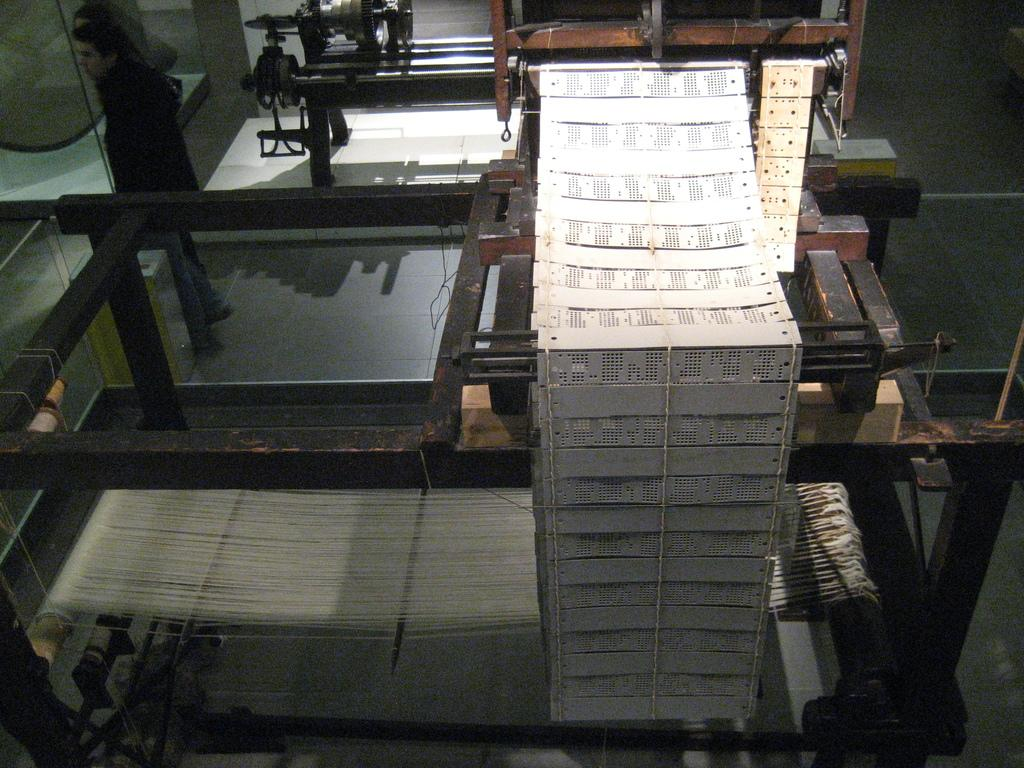What can be seen in the image? There are machines in the image. Can you describe the man's position in the image? A man is standing near a machine in the image. What type of knife is the man using to exercise his muscles in the alley? There is no knife or exercise activity depicted in the image. The image only shows machines and a man standing near one of them. 